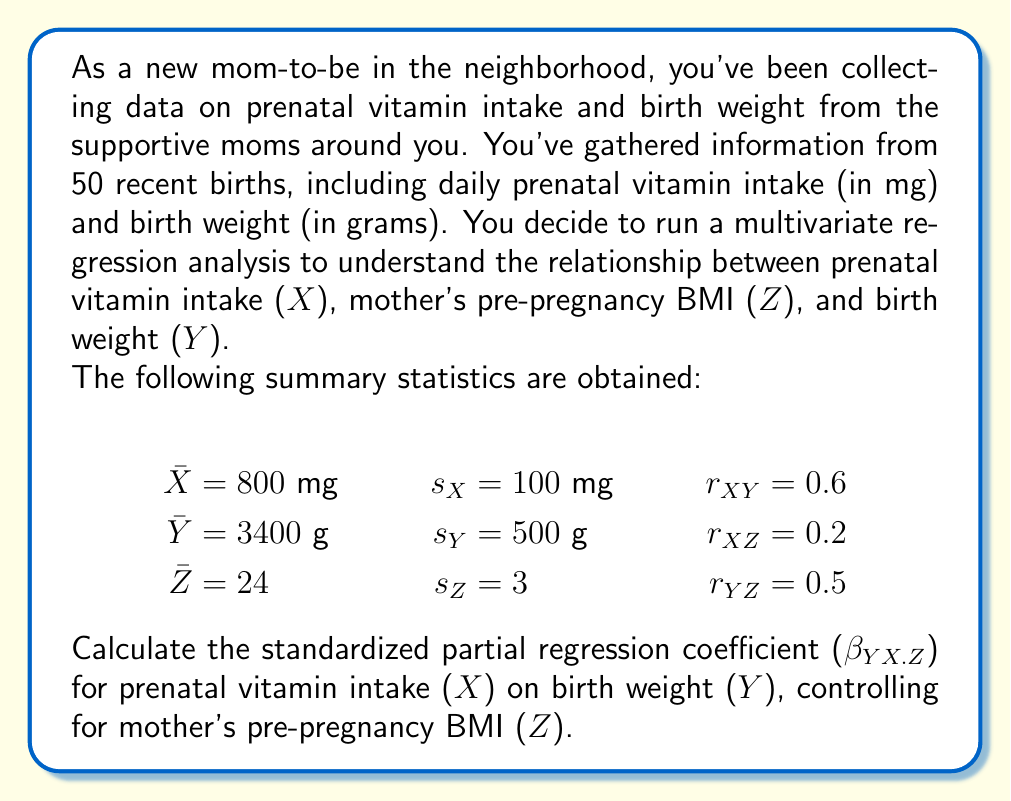Teach me how to tackle this problem. To calculate the standardized partial regression coefficient ($\beta_{YX.Z}$), we'll follow these steps:

1) The formula for the standardized partial regression coefficient is:

   $$\beta_{YX.Z} = \frac{r_{YX} - r_{YZ}r_{XZ}}{\sqrt{1 - r_{XZ}^2}}$$

2) We have all the necessary correlation coefficients:
   $r_{YX} = 0.6$
   $r_{YZ} = 0.5$
   $r_{XZ} = 0.2$

3) Let's substitute these values into the formula:

   $$\beta_{YX.Z} = \frac{0.6 - (0.5)(0.2)}{\sqrt{1 - 0.2^2}}$$

4) First, let's calculate the numerator:
   $0.6 - (0.5)(0.2) = 0.6 - 0.1 = 0.5$

5) Now, let's calculate the denominator:
   $\sqrt{1 - 0.2^2} = \sqrt{1 - 0.04} = \sqrt{0.96} \approx 0.9798$

6) Finally, we can divide:
   $$\beta_{YX.Z} = \frac{0.5}{0.9798} \approx 0.5103$$

Therefore, the standardized partial regression coefficient for prenatal vitamin intake on birth weight, controlling for mother's pre-pregnancy BMI, is approximately 0.5103.
Answer: $\beta_{YX.Z} \approx 0.5103$ 